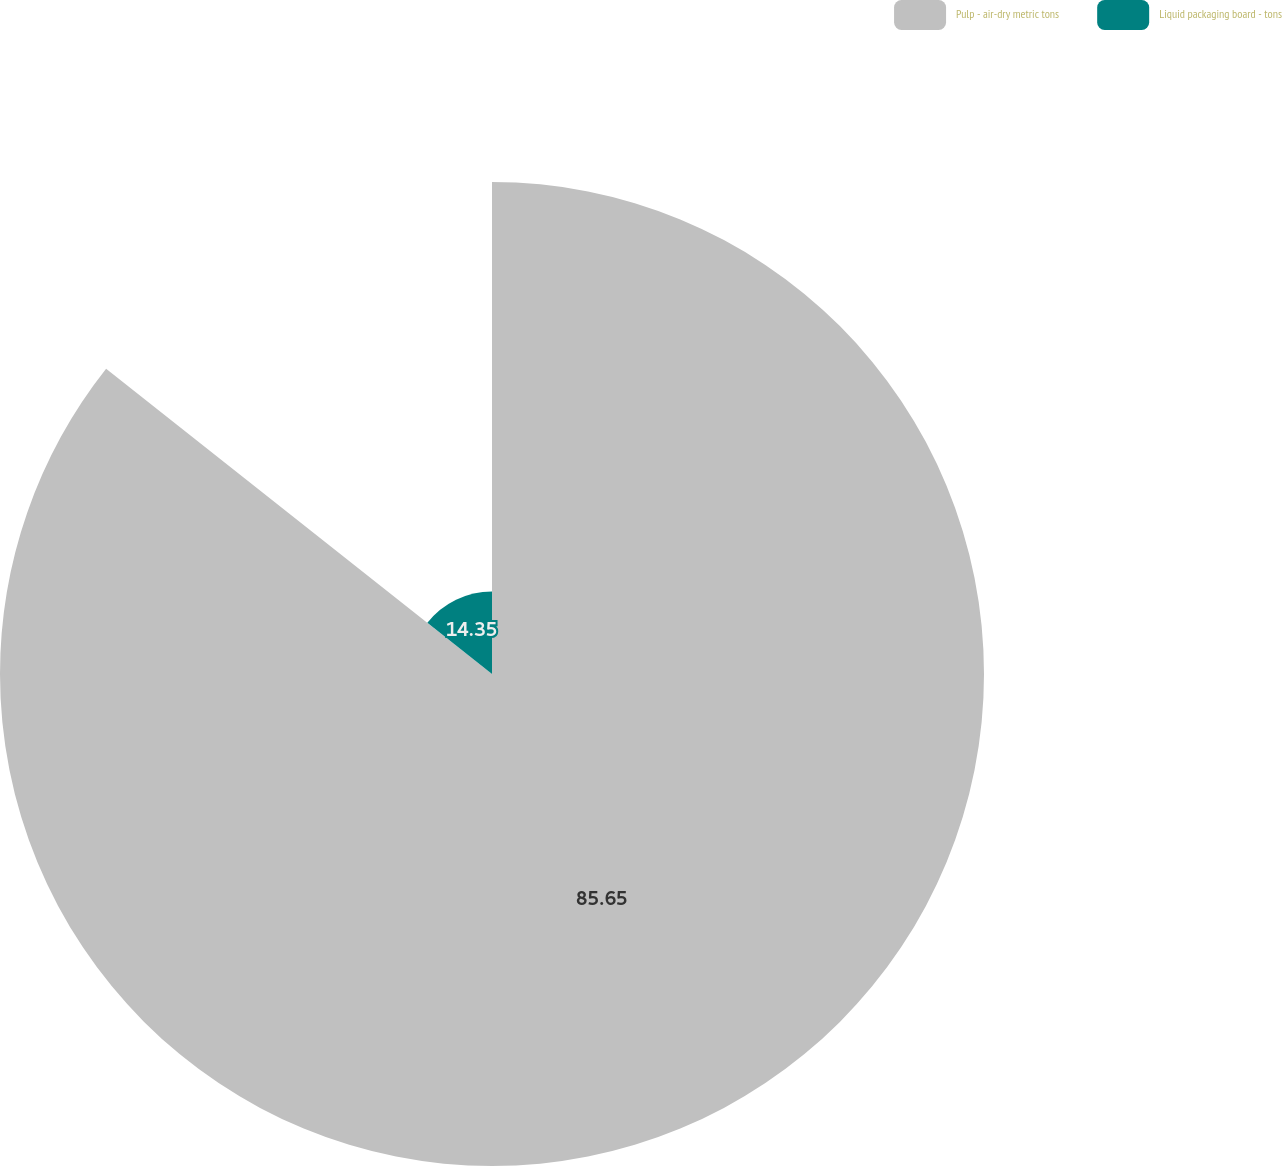Convert chart to OTSL. <chart><loc_0><loc_0><loc_500><loc_500><pie_chart><fcel>Pulp - air-dry metric tons<fcel>Liquid packaging board - tons<nl><fcel>85.65%<fcel>14.35%<nl></chart> 